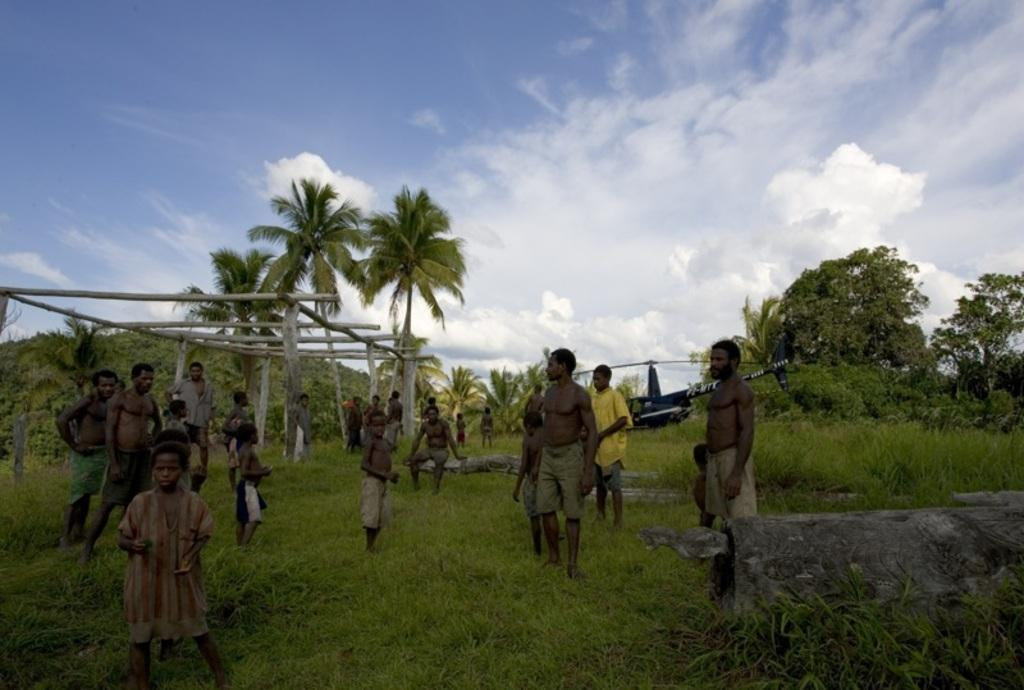Who is present in the image? There are African men and kids in the image. What is the setting of the image? They are standing on grassland. What can be seen in the background of the image? There is a helicopter and trees in the background of the image. What is visible in the sky in the image? The sky is visible in the image, and clouds are present. What type of plants are being used as evidence in the crime scene depicted in the image? There is no crime scene or plants present in the image; it features African men and kids standing on grassland with a helicopter and trees in the background. 